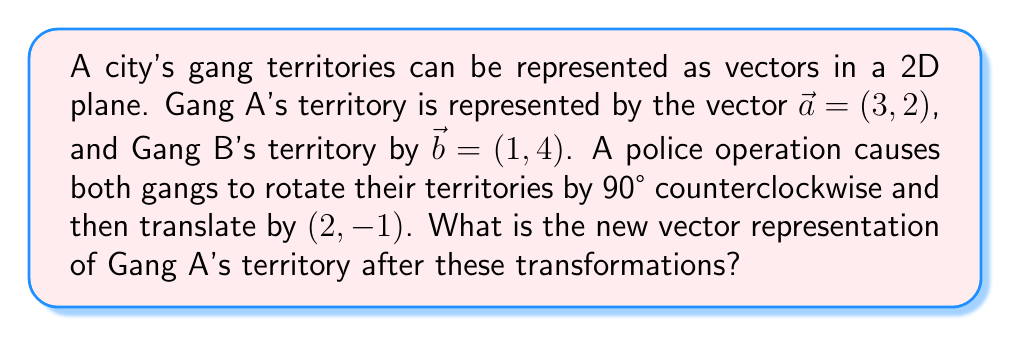Can you solve this math problem? To solve this problem, we'll follow these steps:

1) First, let's recall the rotation matrix for a 90° counterclockwise rotation:

   $$R = \begin{pmatrix} 0 & -1 \\ 1 & 0 \end{pmatrix}$$

2) Apply the rotation to Gang A's territory vector:

   $$R\vec{a} = \begin{pmatrix} 0 & -1 \\ 1 & 0 \end{pmatrix} \begin{pmatrix} 3 \\ 2 \end{pmatrix} = \begin{pmatrix} -2 \\ 3 \end{pmatrix}$$

3) Now, we need to apply the translation $(2, -1)$. In vector notation, this is simply adding the translation vector to our rotated vector:

   $$\vec{a}_{\text{new}} = \begin{pmatrix} -2 \\ 3 \end{pmatrix} + \begin{pmatrix} 2 \\ -1 \end{pmatrix} = \begin{pmatrix} 0 \\ 2 \end{pmatrix}$$

Therefore, the new vector representation of Gang A's territory is $(0, 2)$.
Answer: $(0, 2)$ 